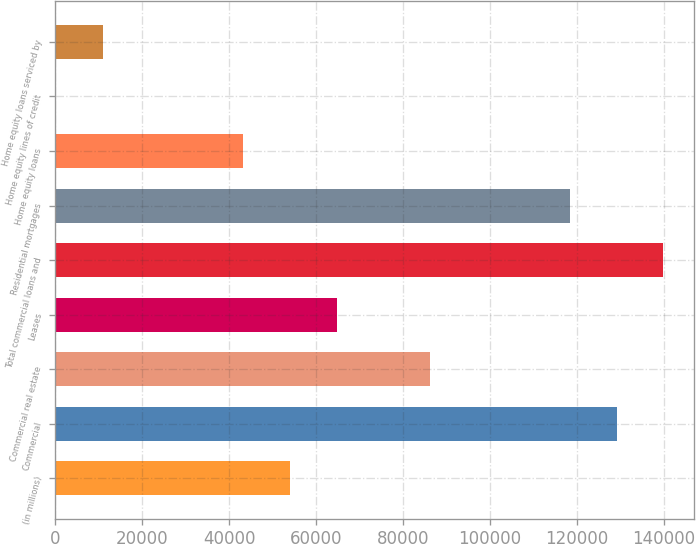<chart> <loc_0><loc_0><loc_500><loc_500><bar_chart><fcel>(in millions)<fcel>Commercial<fcel>Commercial real estate<fcel>Leases<fcel>Total commercial loans and<fcel>Residential mortgages<fcel>Home equity loans<fcel>Home equity lines of credit<fcel>Home equity loans serviced by<nl><fcel>53944<fcel>129159<fcel>86179<fcel>64689<fcel>139904<fcel>118414<fcel>43199<fcel>219<fcel>10964<nl></chart> 